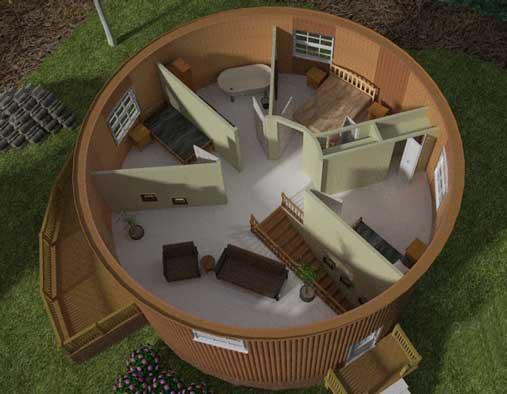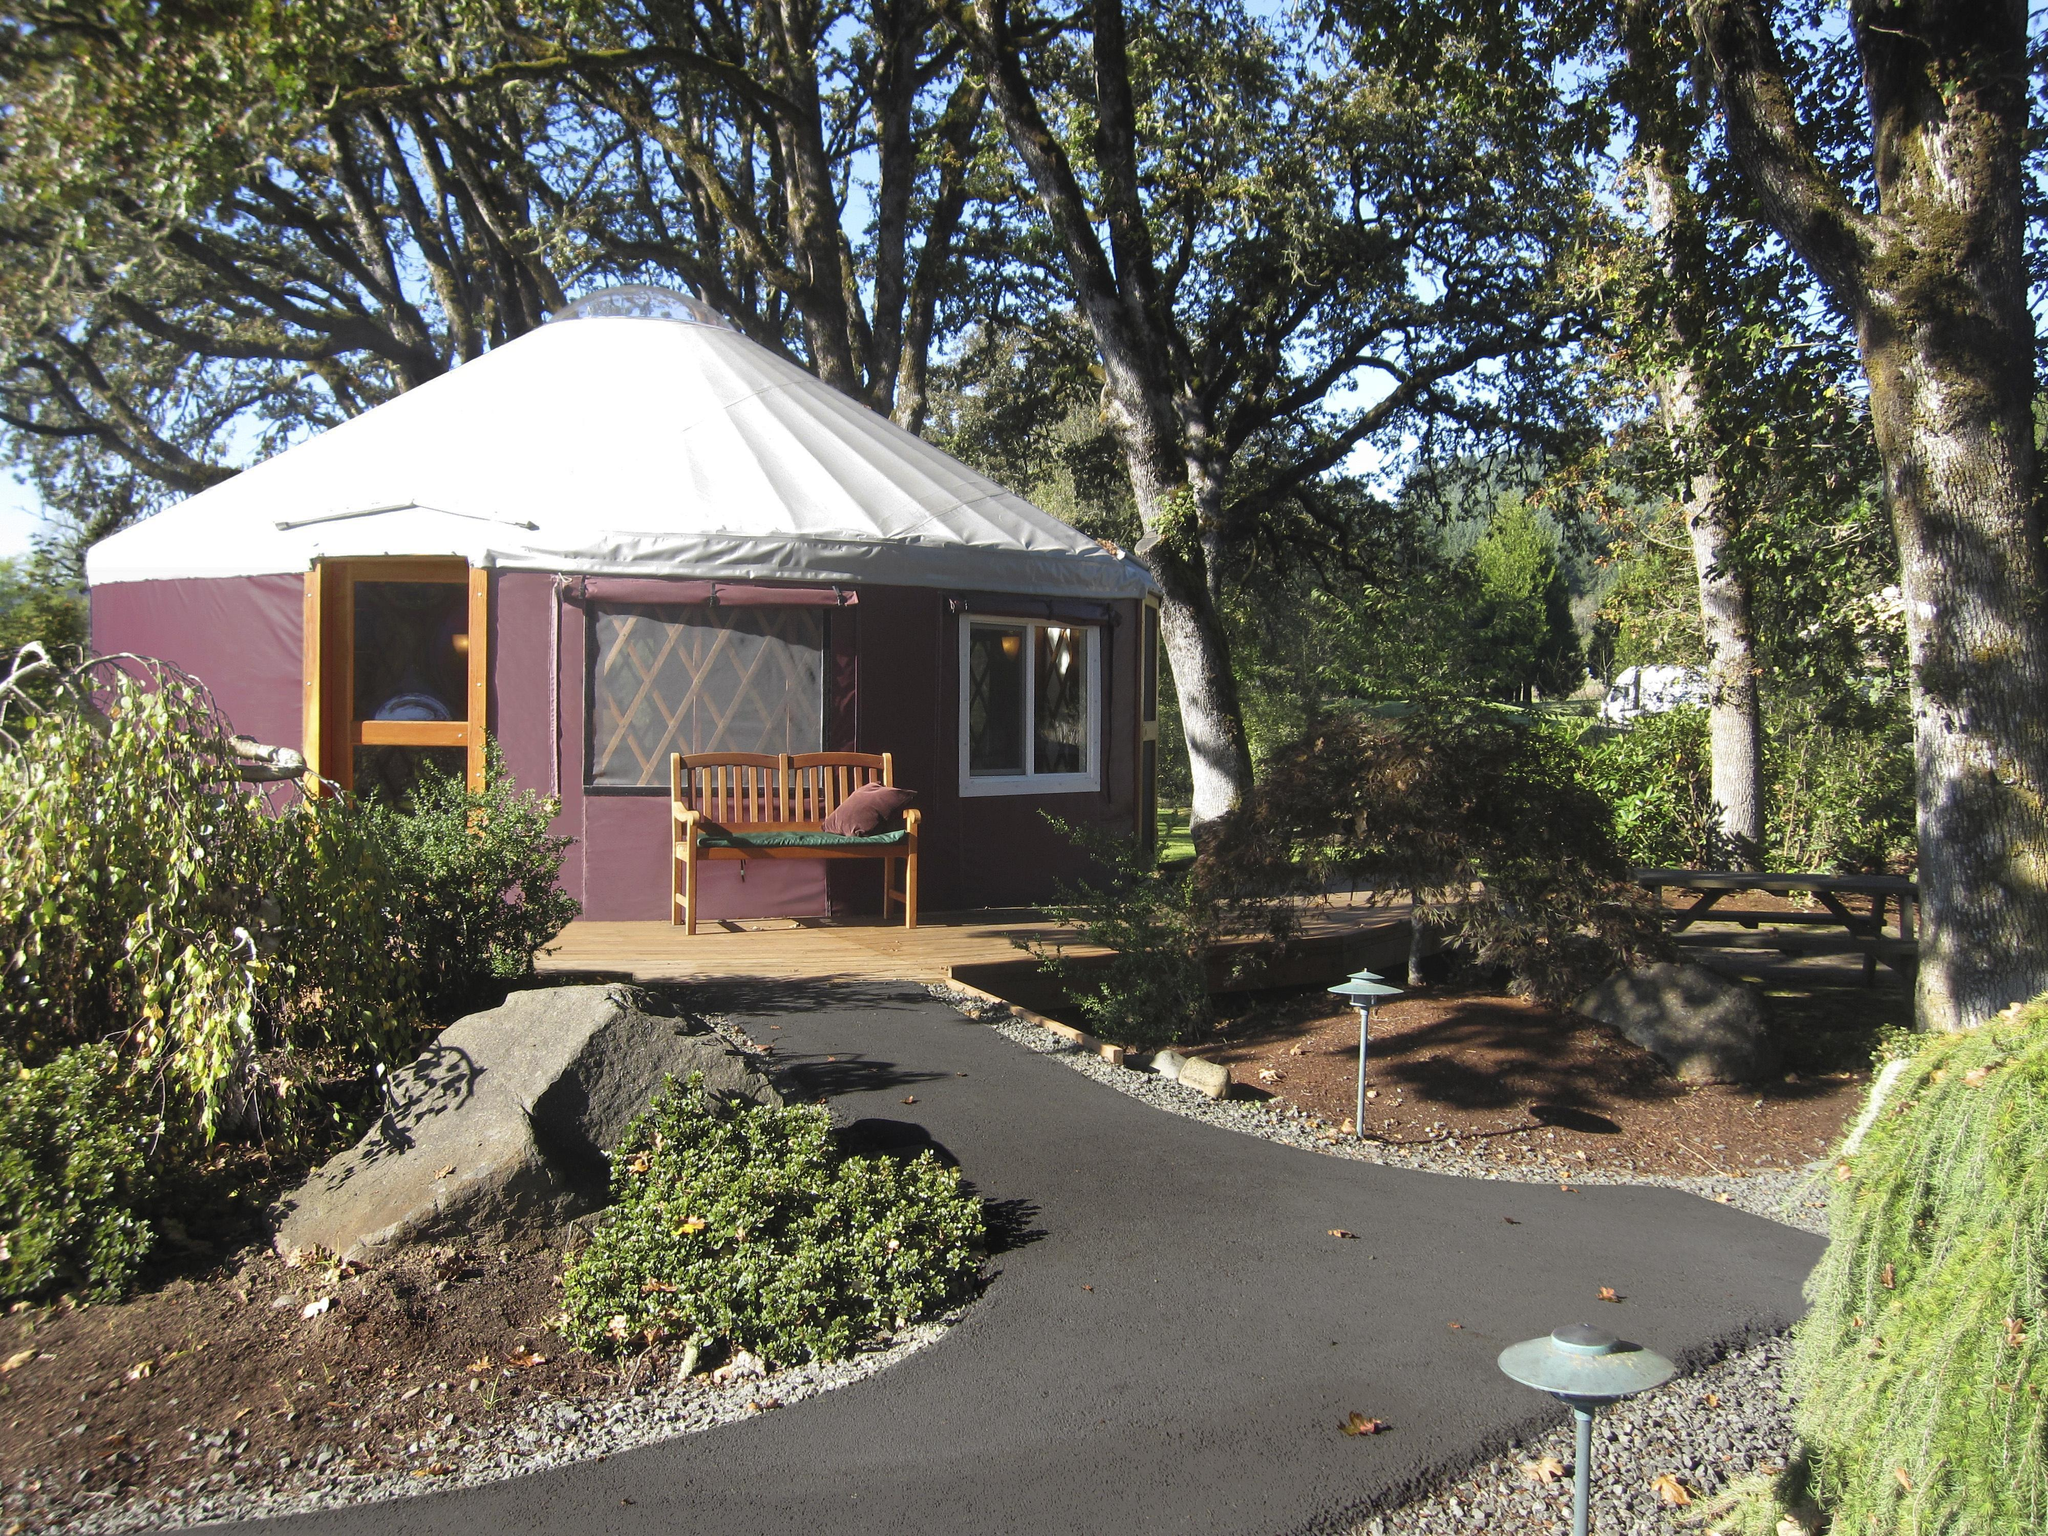The first image is the image on the left, the second image is the image on the right. Evaluate the accuracy of this statement regarding the images: "The interior is shown of the hut in at least one of the images.". Is it true? Answer yes or no. Yes. The first image is the image on the left, the second image is the image on the right. For the images shown, is this caption "At least one image shows a model of a circular building, with a section removed to show the interior." true? Answer yes or no. Yes. 